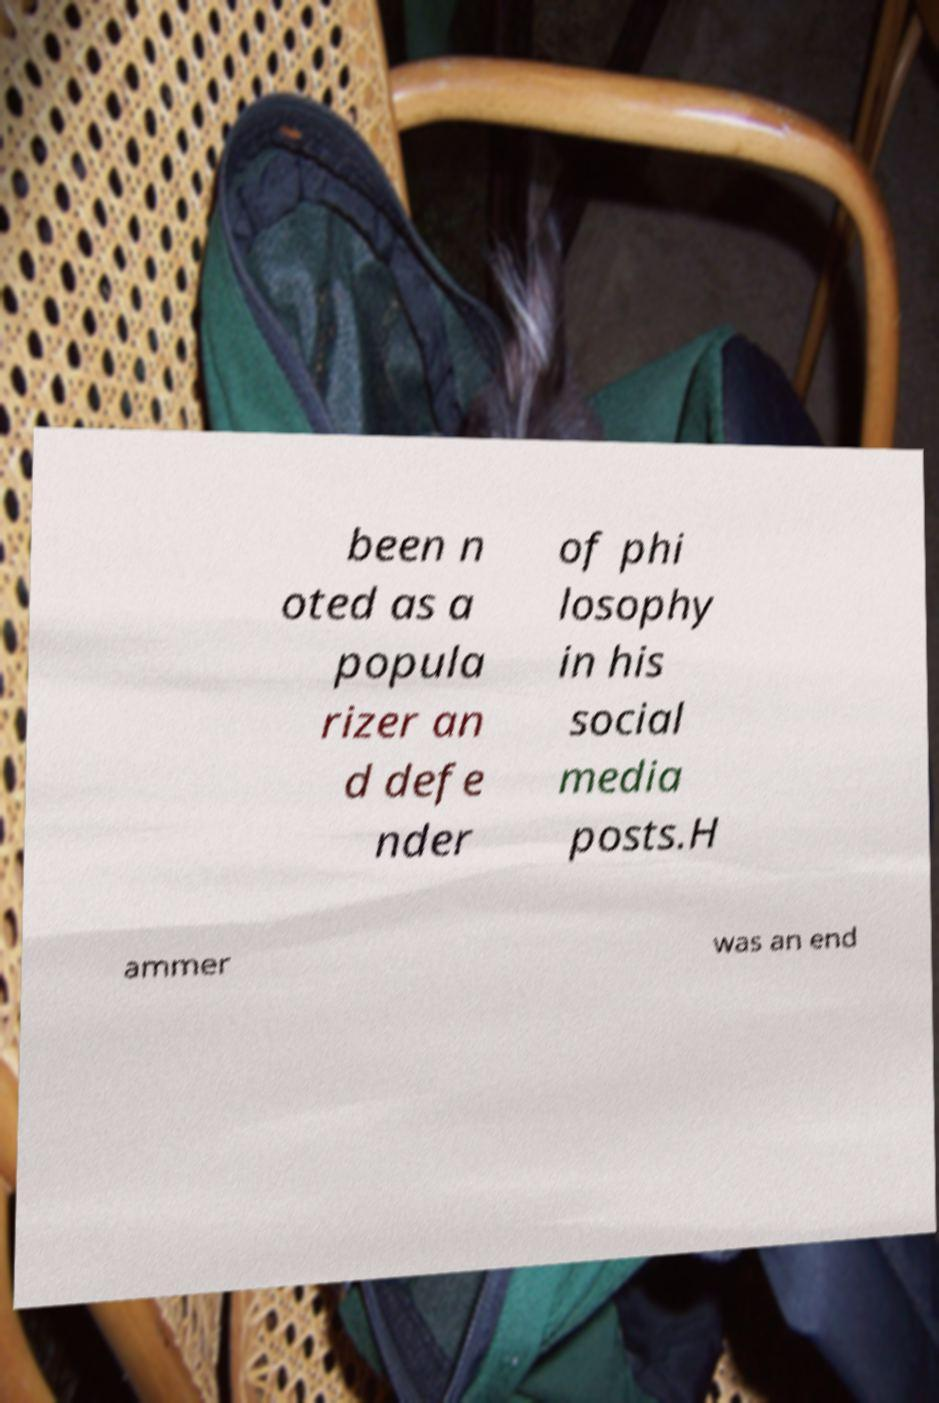There's text embedded in this image that I need extracted. Can you transcribe it verbatim? been n oted as a popula rizer an d defe nder of phi losophy in his social media posts.H ammer was an end 